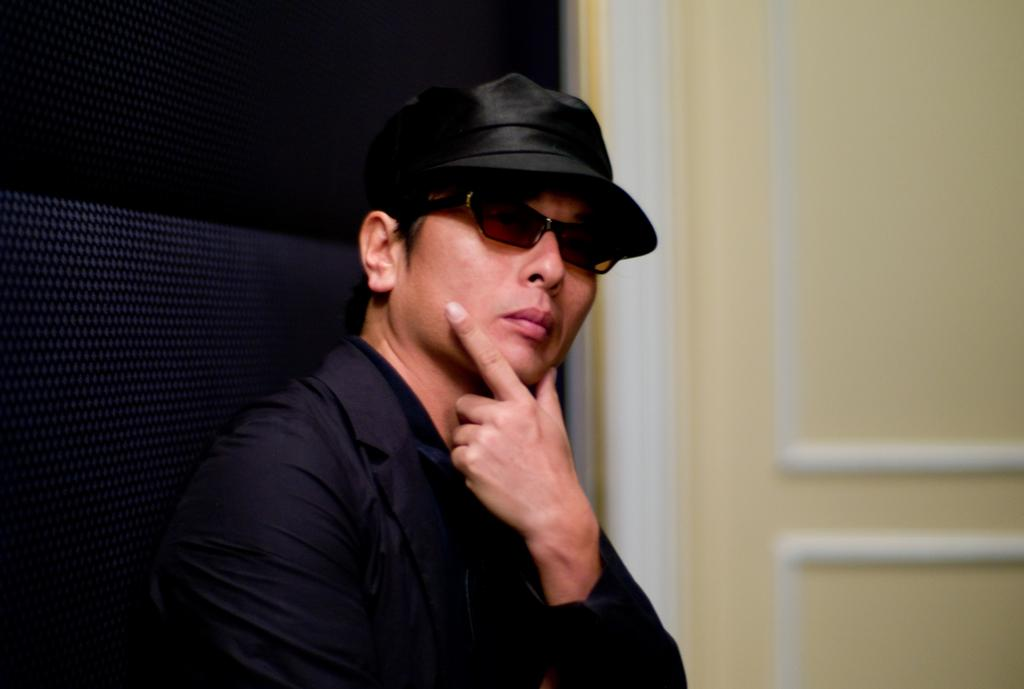What is the main subject of the image? The main subject of the image is a man. Can you describe the man's clothing in the image? The man is wearing a black coat, spectacles, and a cap on his head. What can be seen on the right side of the image? There is a cream-colored wall on the right side of the image. What type of potato is being represented by the man in the image? There is no potato present in the image, and the man is not representing any type of potato. How many trees are visible in the image? There are no trees visible in the image; it only features a man and a cream-colored wall. 